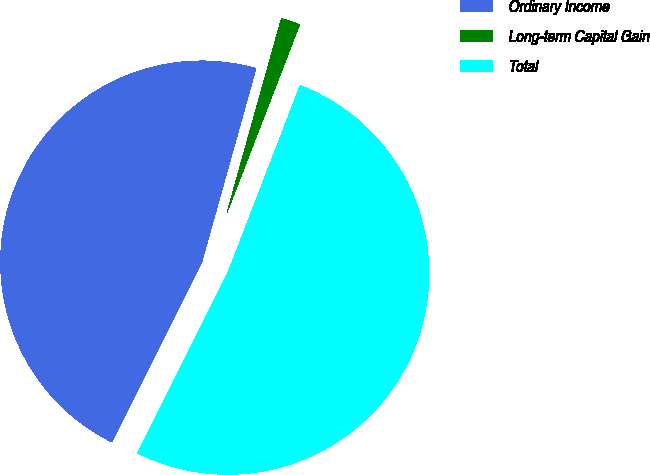<chart> <loc_0><loc_0><loc_500><loc_500><pie_chart><fcel>Ordinary Income<fcel>Long-term Capital Gain<fcel>Total<nl><fcel>46.97%<fcel>1.52%<fcel>51.51%<nl></chart> 